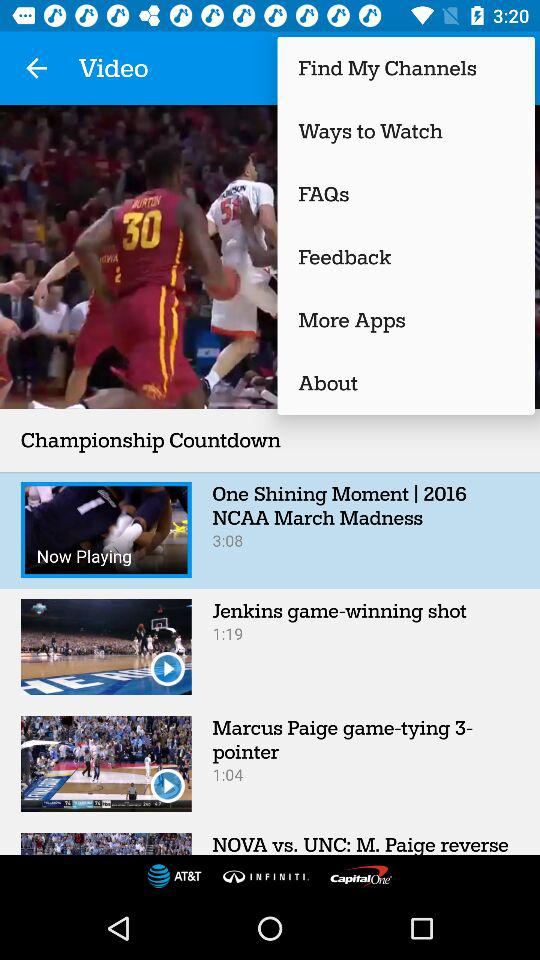Which video is currently playing? The video "One Shining Moment | 2016 NCAA March Madness" is currently playing. 